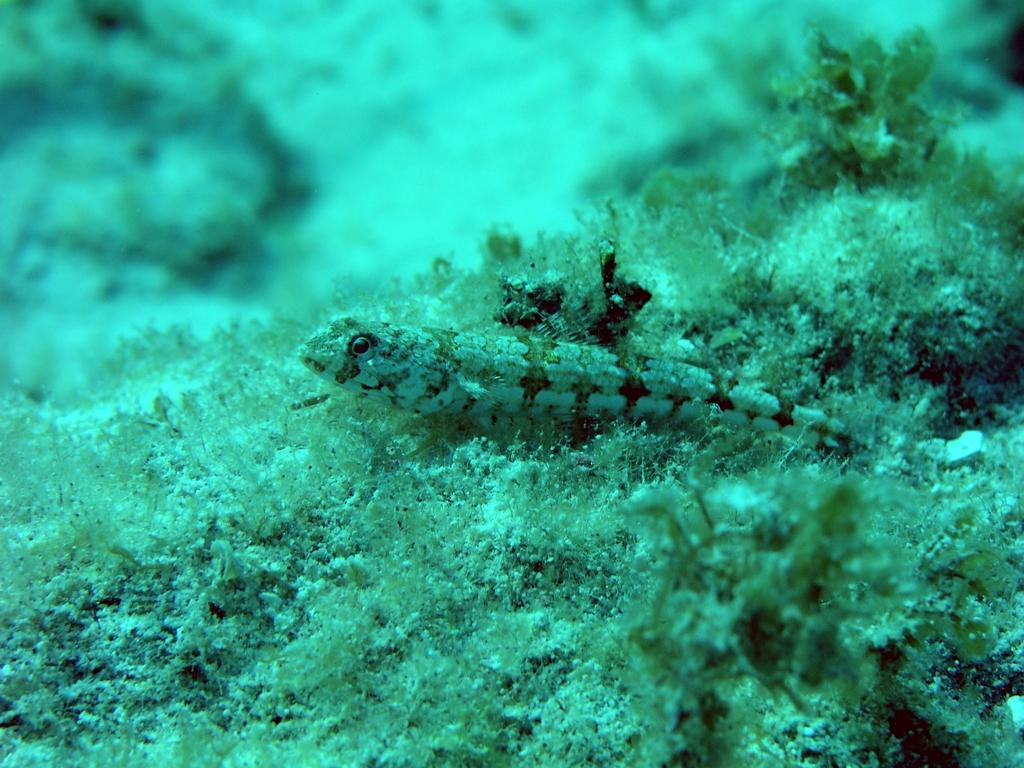What is the main subject of the image? The main subject of the image is the water surface. Can you describe any living organisms visible in the water? Yes, there is a fish visible in the water. What type of vegetation can be seen in the image? There are water plants present in the image. What type of question is the fish asking in the image? There is no indication in the image that the fish is asking a question, as fish do not have the ability to speak or ask questions. 